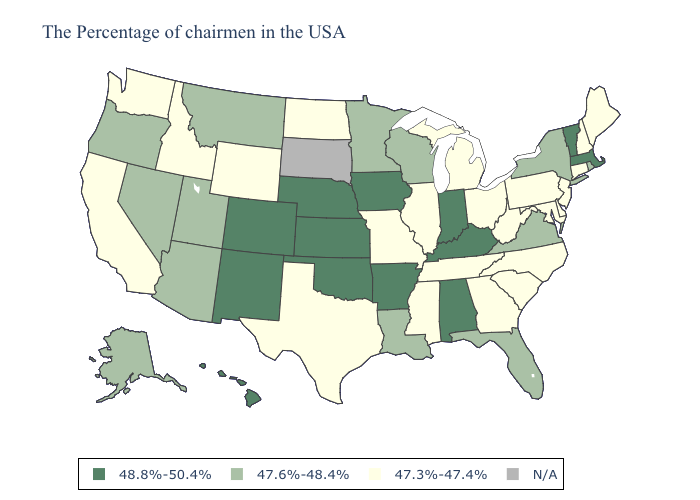What is the value of Nevada?
Be succinct. 47.6%-48.4%. Which states have the highest value in the USA?
Give a very brief answer. Massachusetts, Vermont, Kentucky, Indiana, Alabama, Arkansas, Iowa, Kansas, Nebraska, Oklahoma, Colorado, New Mexico, Hawaii. Name the states that have a value in the range 48.8%-50.4%?
Write a very short answer. Massachusetts, Vermont, Kentucky, Indiana, Alabama, Arkansas, Iowa, Kansas, Nebraska, Oklahoma, Colorado, New Mexico, Hawaii. What is the highest value in states that border Delaware?
Concise answer only. 47.3%-47.4%. Does Wisconsin have the highest value in the USA?
Write a very short answer. No. Does the map have missing data?
Concise answer only. Yes. Does Idaho have the highest value in the USA?
Write a very short answer. No. Is the legend a continuous bar?
Answer briefly. No. What is the lowest value in the South?
Write a very short answer. 47.3%-47.4%. Which states have the lowest value in the Northeast?
Keep it brief. Maine, New Hampshire, Connecticut, New Jersey, Pennsylvania. What is the value of Ohio?
Short answer required. 47.3%-47.4%. Name the states that have a value in the range N/A?
Be succinct. South Dakota. What is the highest value in the USA?
Keep it brief. 48.8%-50.4%. Does Missouri have the lowest value in the MidWest?
Keep it brief. Yes. 